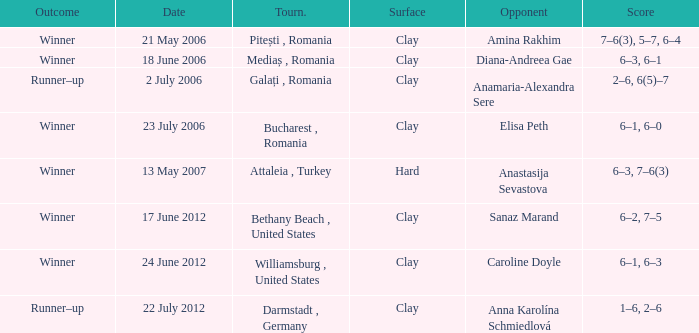Can you give me this table as a dict? {'header': ['Outcome', 'Date', 'Tourn.', 'Surface', 'Opponent', 'Score'], 'rows': [['Winner', '21 May 2006', 'Pitești , Romania', 'Clay', 'Amina Rakhim', '7–6(3), 5–7, 6–4'], ['Winner', '18 June 2006', 'Mediaș , Romania', 'Clay', 'Diana-Andreea Gae', '6–3, 6–1'], ['Runner–up', '2 July 2006', 'Galați , Romania', 'Clay', 'Anamaria-Alexandra Sere', '2–6, 6(5)–7'], ['Winner', '23 July 2006', 'Bucharest , Romania', 'Clay', 'Elisa Peth', '6–1, 6–0'], ['Winner', '13 May 2007', 'Attaleia , Turkey', 'Hard', 'Anastasija Sevastova', '6–3, 7–6(3)'], ['Winner', '17 June 2012', 'Bethany Beach , United States', 'Clay', 'Sanaz Marand', '6–2, 7–5'], ['Winner', '24 June 2012', 'Williamsburg , United States', 'Clay', 'Caroline Doyle', '6–1, 6–3'], ['Runner–up', '22 July 2012', 'Darmstadt , Germany', 'Clay', 'Anna Karolína Schmiedlová', '1–6, 2–6']]} What tournament was held on 21 May 2006? Pitești , Romania. 